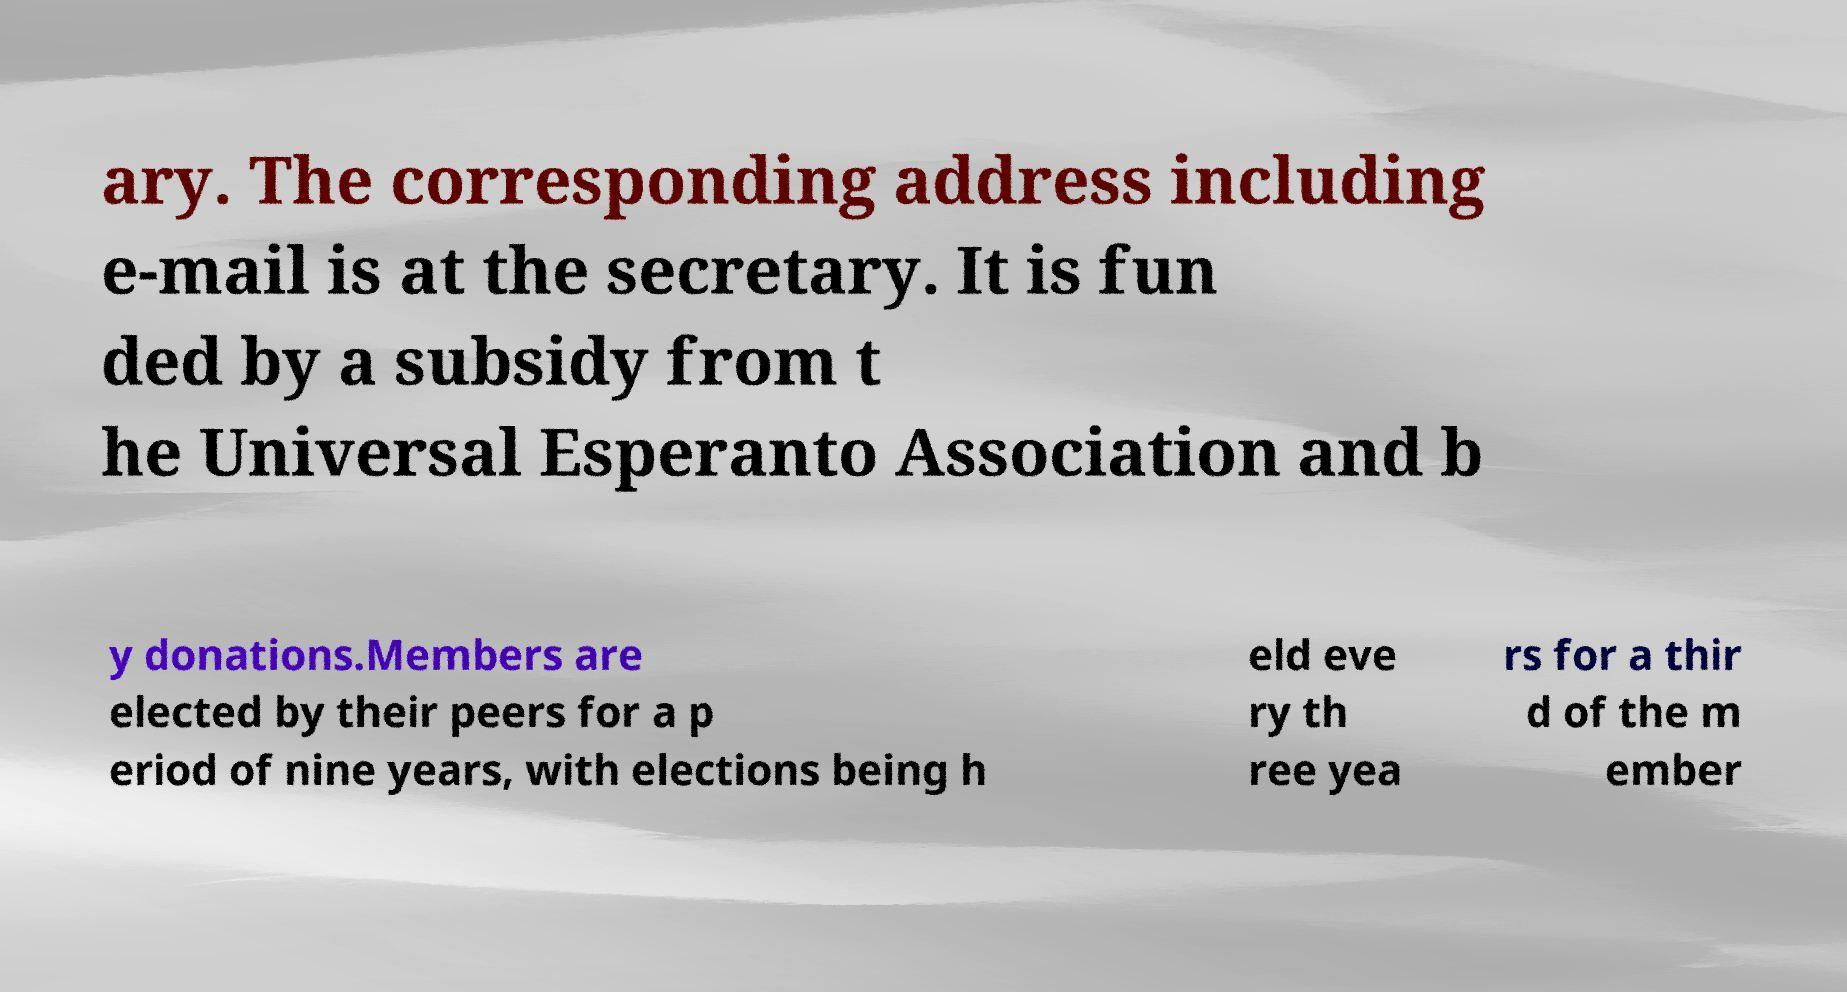Could you assist in decoding the text presented in this image and type it out clearly? ary. The corresponding address including e-mail is at the secretary. It is fun ded by a subsidy from t he Universal Esperanto Association and b y donations.Members are elected by their peers for a p eriod of nine years, with elections being h eld eve ry th ree yea rs for a thir d of the m ember 